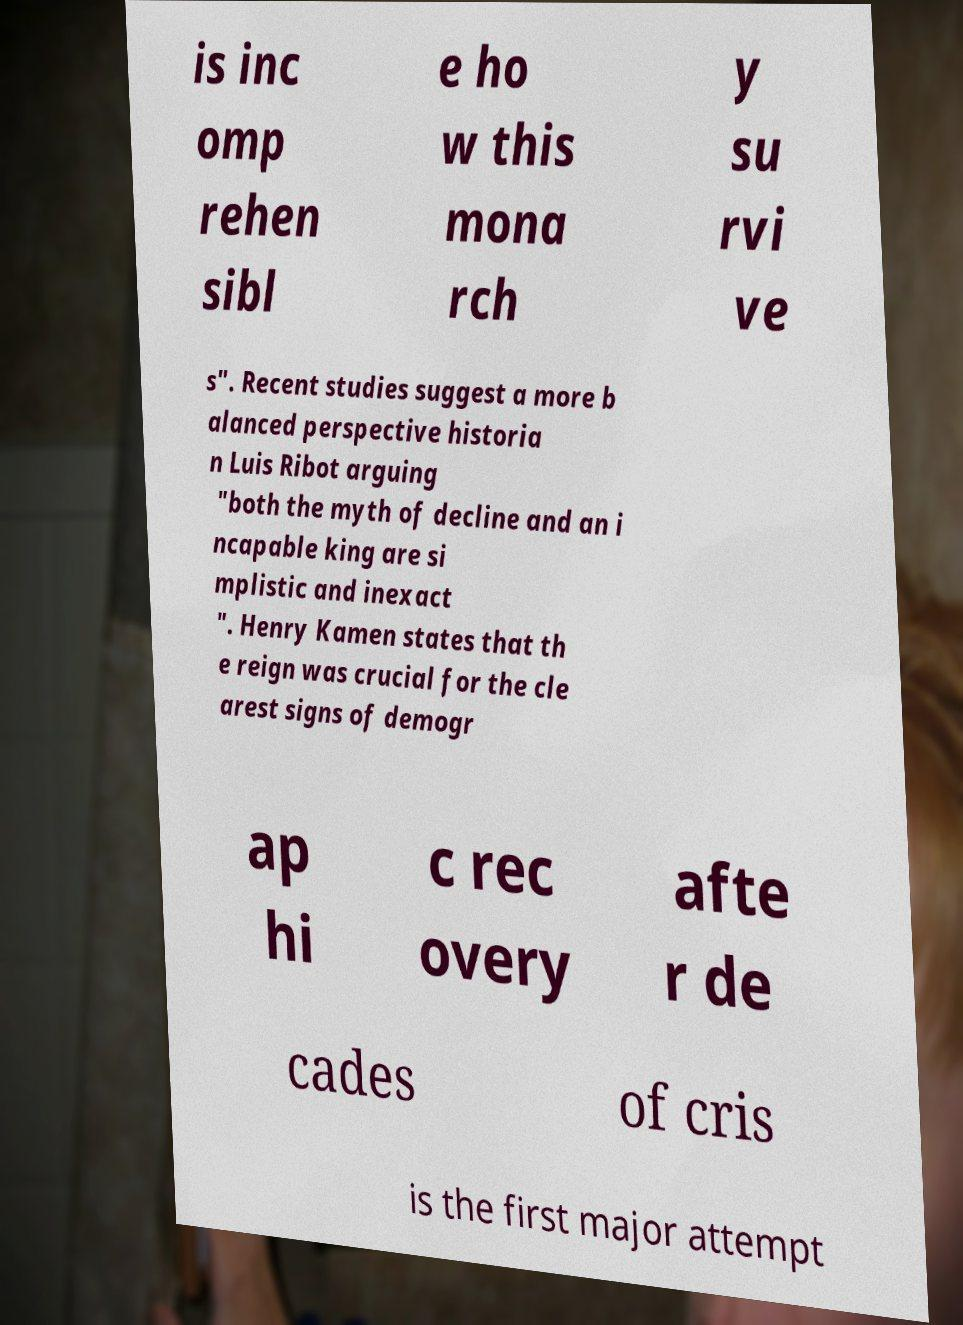I need the written content from this picture converted into text. Can you do that? is inc omp rehen sibl e ho w this mona rch y su rvi ve s". Recent studies suggest a more b alanced perspective historia n Luis Ribot arguing "both the myth of decline and an i ncapable king are si mplistic and inexact ". Henry Kamen states that th e reign was crucial for the cle arest signs of demogr ap hi c rec overy afte r de cades of cris is the first major attempt 